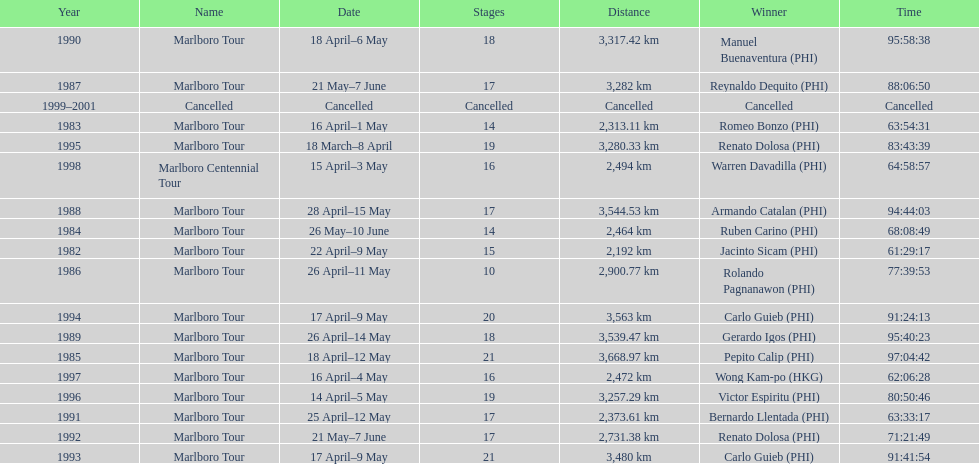What was the largest distance traveled for the marlboro tour? 3,668.97 km. I'm looking to parse the entire table for insights. Could you assist me with that? {'header': ['Year', 'Name', 'Date', 'Stages', 'Distance', 'Winner', 'Time'], 'rows': [['1990', 'Marlboro Tour', '18 April–6 May', '18', '3,317.42\xa0km', 'Manuel Buenaventura\xa0(PHI)', '95:58:38'], ['1987', 'Marlboro Tour', '21 May–7 June', '17', '3,282\xa0km', 'Reynaldo Dequito\xa0(PHI)', '88:06:50'], ['1999–2001', 'Cancelled', 'Cancelled', 'Cancelled', 'Cancelled', 'Cancelled', 'Cancelled'], ['1983', 'Marlboro Tour', '16 April–1 May', '14', '2,313.11\xa0km', 'Romeo Bonzo\xa0(PHI)', '63:54:31'], ['1995', 'Marlboro Tour', '18 March–8 April', '19', '3,280.33\xa0km', 'Renato Dolosa\xa0(PHI)', '83:43:39'], ['1998', 'Marlboro Centennial Tour', '15 April–3 May', '16', '2,494\xa0km', 'Warren Davadilla\xa0(PHI)', '64:58:57'], ['1988', 'Marlboro Tour', '28 April–15 May', '17', '3,544.53\xa0km', 'Armando Catalan\xa0(PHI)', '94:44:03'], ['1984', 'Marlboro Tour', '26 May–10 June', '14', '2,464\xa0km', 'Ruben Carino\xa0(PHI)', '68:08:49'], ['1982', 'Marlboro Tour', '22 April–9 May', '15', '2,192\xa0km', 'Jacinto Sicam\xa0(PHI)', '61:29:17'], ['1986', 'Marlboro Tour', '26 April–11 May', '10', '2,900.77\xa0km', 'Rolando Pagnanawon\xa0(PHI)', '77:39:53'], ['1994', 'Marlboro Tour', '17 April–9 May', '20', '3,563\xa0km', 'Carlo Guieb\xa0(PHI)', '91:24:13'], ['1989', 'Marlboro Tour', '26 April–14 May', '18', '3,539.47\xa0km', 'Gerardo Igos\xa0(PHI)', '95:40:23'], ['1985', 'Marlboro Tour', '18 April–12 May', '21', '3,668.97\xa0km', 'Pepito Calip\xa0(PHI)', '97:04:42'], ['1997', 'Marlboro Tour', '16 April–4 May', '16', '2,472\xa0km', 'Wong Kam-po\xa0(HKG)', '62:06:28'], ['1996', 'Marlboro Tour', '14 April–5 May', '19', '3,257.29\xa0km', 'Victor Espiritu\xa0(PHI)', '80:50:46'], ['1991', 'Marlboro Tour', '25 April–12 May', '17', '2,373.61\xa0km', 'Bernardo Llentada\xa0(PHI)', '63:33:17'], ['1992', 'Marlboro Tour', '21 May–7 June', '17', '2,731.38\xa0km', 'Renato Dolosa\xa0(PHI)', '71:21:49'], ['1993', 'Marlboro Tour', '17 April–9 May', '21', '3,480\xa0km', 'Carlo Guieb\xa0(PHI)', '91:41:54']]} 